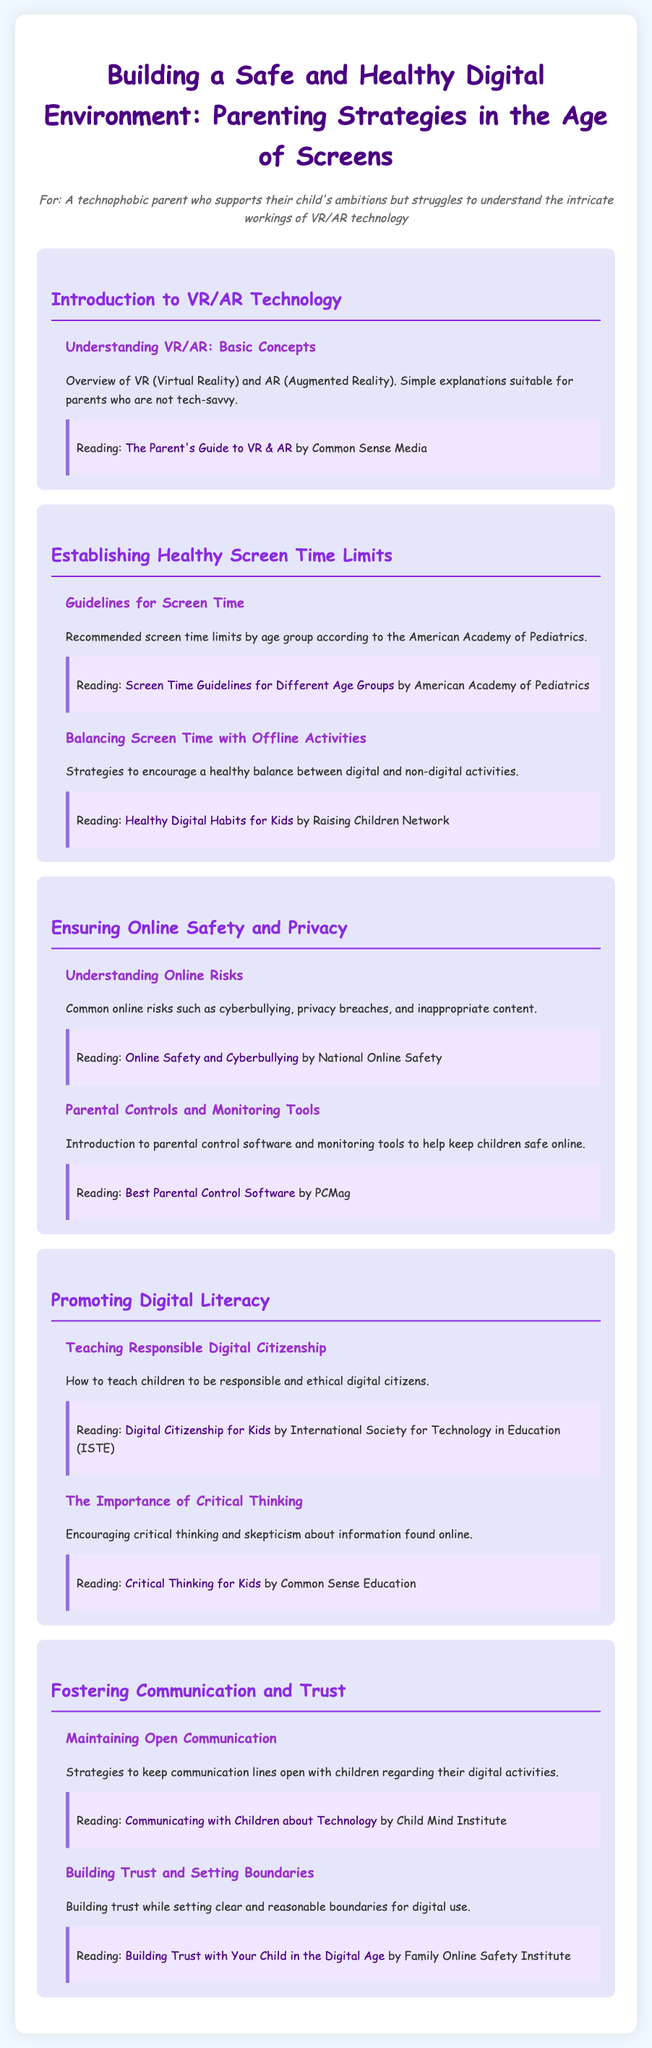What is the title of the syllabus? The title of the syllabus is highlighted at the top of the document, which specifies the main topic covered in the content.
Answer: Building a Safe and Healthy Digital Environment: Parenting Strategies in the Age of Screens What is one resource provided in the Introduction to VR/AR Technology? The section lists a specific reading resource along with its title and source, providing parents guidance on VR and AR concepts.
Answer: The Parent's Guide to VR & AR What organization provides screen time guidelines? The document mentions an established organization that offers recommendations for screen time limits based on age, identified within the module.
Answer: American Academy of Pediatrics What are two topics covered under Ensuring Online Safety and Privacy? The document includes multiple relevant topics within the module that focus on safety online, which could be combined for this information.
Answer: Understanding Online Risks, Parental Controls and Monitoring Tools What is a strategy mentioned for promoting digital literacy? The syllabus outlines methods for fostering responsible behavior online, which parents can teach their children.
Answer: Teaching Responsible Digital Citizenship How many modules are included in the syllabus? The document lists distinct modules, indicating the various focus areas for the syllabus, allowing parents to understand the scope of the content.
Answer: Five In the section about Fostering Communication and Trust, what is one key focus? The module emphasizes essential discussions that parents should maintain with their children regarding their digital experiences, which is highlighted in the content.
Answer: Maintaining Open Communication 